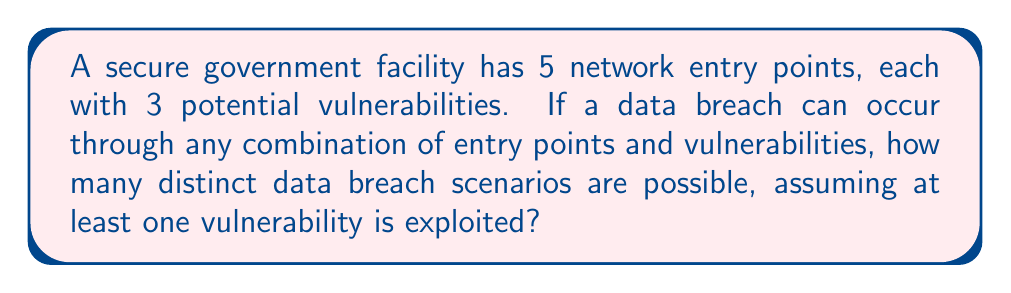Show me your answer to this math problem. Let's approach this step-by-step:

1) For each entry point, we have 3 vulnerabilities. Each vulnerability can be either exploited or not exploited. This gives us 2 choices for each vulnerability.

2) For a single entry point, the number of possible scenarios is $2^3 = 8$. However, we need to subtract the case where no vulnerability is exploited. So, for each entry point, we have 7 possible scenarios.

3) We have 5 entry points in total. To find all possible combinations, we use the multiplication principle.

4) The total number of scenarios would be $7^5$ if we considered all cases. However, we need to subtract the case where no entry point is breached.

5) Therefore, the number of distinct data breach scenarios is:

   $$7^5 - 1 = 16807 - 1 = 16806$$

This can be represented mathematically as:

$$\sum_{k=1}^{5} \binom{5}{k} (2^3 - 1)^k = (2^3 - 1)^5 - 1 = 7^5 - 1 = 16806$$

Where $\binom{5}{k}$ represents the number of ways to choose k entry points out of 5, and $(2^3 - 1)^k$ represents the number of ways to exploit at least one vulnerability in k entry points.
Answer: 16806 